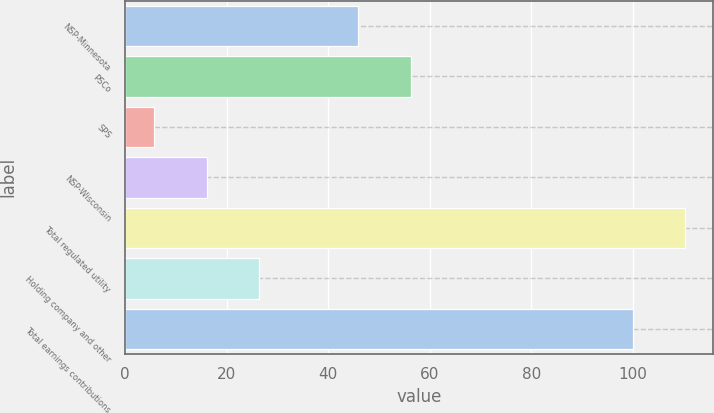Convert chart. <chart><loc_0><loc_0><loc_500><loc_500><bar_chart><fcel>NSP-Minnesota<fcel>PSCo<fcel>SPS<fcel>NSP-Wisconsin<fcel>Total regulated utility<fcel>Holding company and other<fcel>Total earnings contributions<nl><fcel>45.9<fcel>56.24<fcel>5.7<fcel>16.04<fcel>110.34<fcel>26.38<fcel>100<nl></chart> 